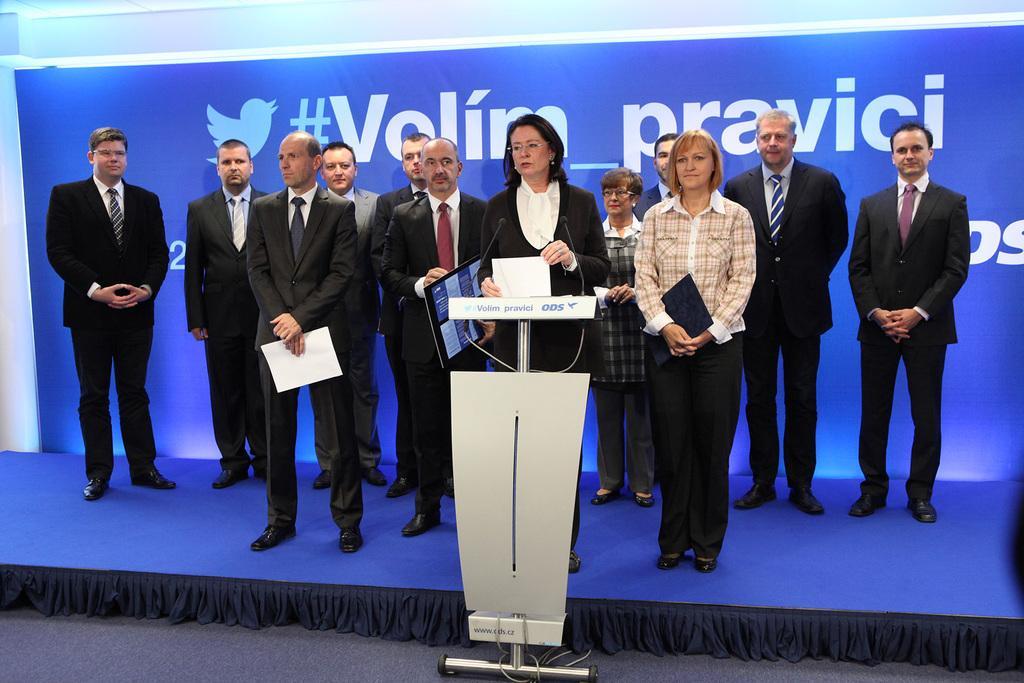Please provide a concise description of this image. In this picture we can see a group of people standing on stage where a woman holding a paper with her hands and standing at the podium and in the background we can see a banner. 